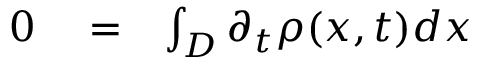Convert formula to latex. <formula><loc_0><loc_0><loc_500><loc_500>\begin{array} { r l r } { 0 } & = } & { \int _ { D } \partial _ { t } \rho ( x , t ) d x } \end{array}</formula> 